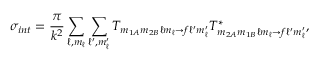Convert formula to latex. <formula><loc_0><loc_0><loc_500><loc_500>\sigma _ { i n t } = \frac { \pi } { k ^ { 2 } } \sum _ { \ell , m _ { \ell } } \sum _ { \ell ^ { \prime } , m _ { \ell } ^ { \prime } } T _ { m _ { 1 A } m _ { 2 B } \ell m _ { \ell } \rightarrow f \ell ^ { \prime } m _ { \ell } ^ { \prime } } T _ { m _ { 2 A } m _ { 1 B } \ell m _ { \ell } \rightarrow f \ell ^ { \prime } m _ { \ell } ^ { \prime } } ^ { * } ,</formula> 